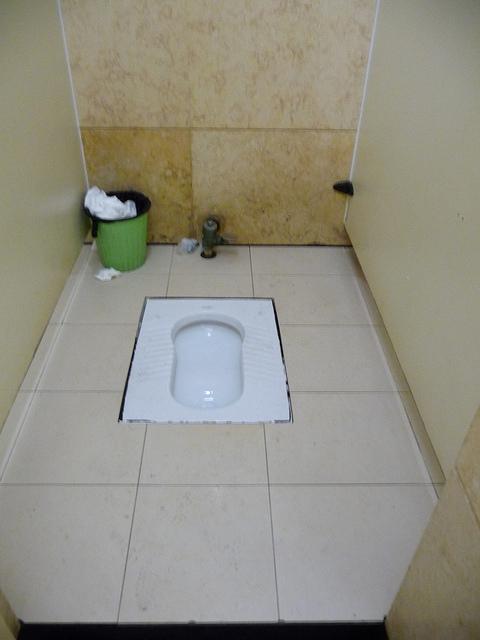What goes in the whole of this floor?
Give a very brief answer. Waste. Does the trash need to be emptied?
Quick response, please. Yes. Is this a public restroom?
Write a very short answer. Yes. Is this a sink?
Answer briefly. No. What color is the trash can?
Answer briefly. Green. 